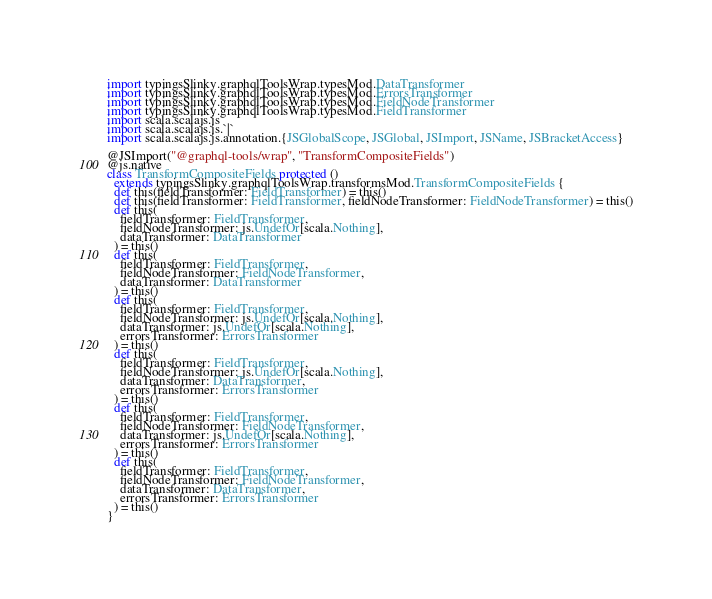<code> <loc_0><loc_0><loc_500><loc_500><_Scala_>import typingsSlinky.graphqlToolsWrap.typesMod.DataTransformer
import typingsSlinky.graphqlToolsWrap.typesMod.ErrorsTransformer
import typingsSlinky.graphqlToolsWrap.typesMod.FieldNodeTransformer
import typingsSlinky.graphqlToolsWrap.typesMod.FieldTransformer
import scala.scalajs.js
import scala.scalajs.js.`|`
import scala.scalajs.js.annotation.{JSGlobalScope, JSGlobal, JSImport, JSName, JSBracketAccess}

@JSImport("@graphql-tools/wrap", "TransformCompositeFields")
@js.native
class TransformCompositeFields protected ()
  extends typingsSlinky.graphqlToolsWrap.transformsMod.TransformCompositeFields {
  def this(fieldTransformer: FieldTransformer) = this()
  def this(fieldTransformer: FieldTransformer, fieldNodeTransformer: FieldNodeTransformer) = this()
  def this(
    fieldTransformer: FieldTransformer,
    fieldNodeTransformer: js.UndefOr[scala.Nothing],
    dataTransformer: DataTransformer
  ) = this()
  def this(
    fieldTransformer: FieldTransformer,
    fieldNodeTransformer: FieldNodeTransformer,
    dataTransformer: DataTransformer
  ) = this()
  def this(
    fieldTransformer: FieldTransformer,
    fieldNodeTransformer: js.UndefOr[scala.Nothing],
    dataTransformer: js.UndefOr[scala.Nothing],
    errorsTransformer: ErrorsTransformer
  ) = this()
  def this(
    fieldTransformer: FieldTransformer,
    fieldNodeTransformer: js.UndefOr[scala.Nothing],
    dataTransformer: DataTransformer,
    errorsTransformer: ErrorsTransformer
  ) = this()
  def this(
    fieldTransformer: FieldTransformer,
    fieldNodeTransformer: FieldNodeTransformer,
    dataTransformer: js.UndefOr[scala.Nothing],
    errorsTransformer: ErrorsTransformer
  ) = this()
  def this(
    fieldTransformer: FieldTransformer,
    fieldNodeTransformer: FieldNodeTransformer,
    dataTransformer: DataTransformer,
    errorsTransformer: ErrorsTransformer
  ) = this()
}
</code> 